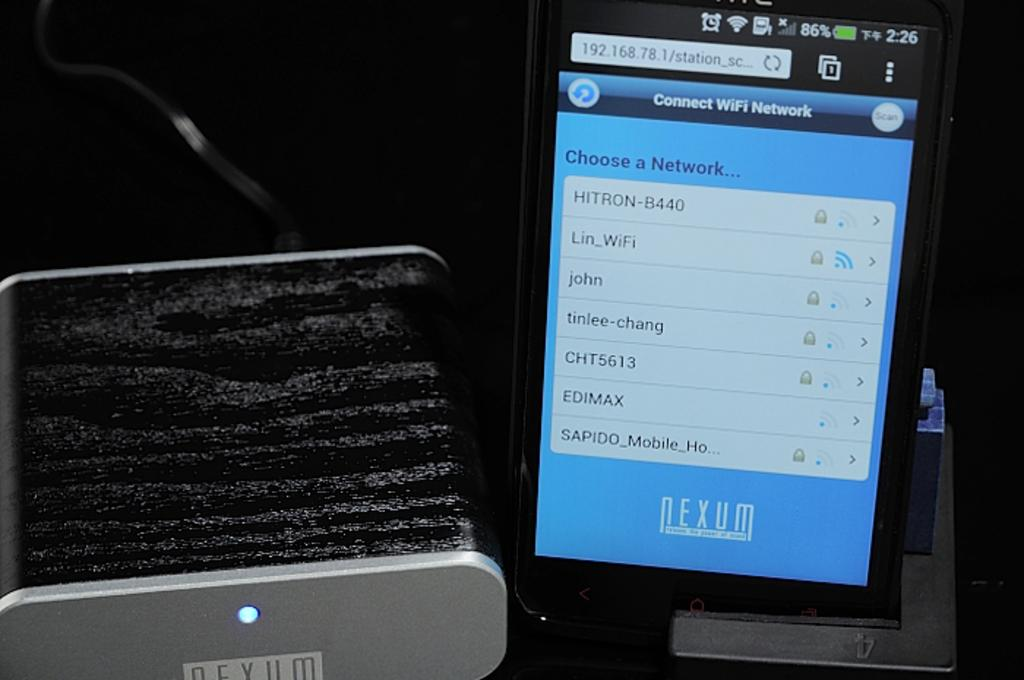<image>
Describe the image concisely. The screen shows that the device has an 86% charge. 